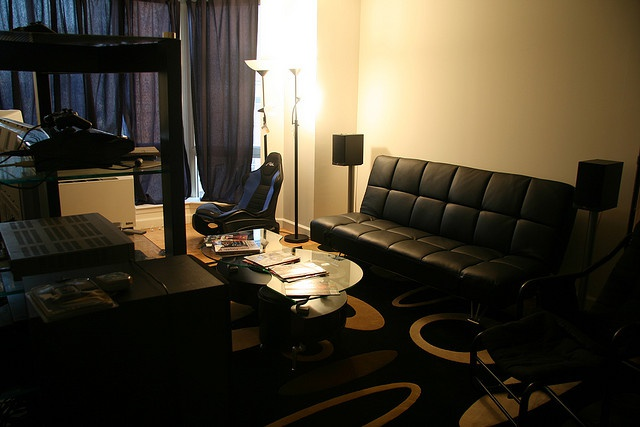Describe the objects in this image and their specific colors. I can see couch in blue, black, gray, and olive tones, chair in blue, black, maroon, and gray tones, dining table in blue, black, tan, and ivory tones, tv in blue, black, and gray tones, and chair in blue, black, and gray tones in this image. 